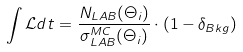Convert formula to latex. <formula><loc_0><loc_0><loc_500><loc_500>\int \mathcal { L } d t = \frac { N _ { L A B } ( \Theta _ { i } ) } { \sigma _ { L A B } ^ { M C } ( \Theta _ { i } ) } \cdot ( 1 - \delta _ { B k g } )</formula> 